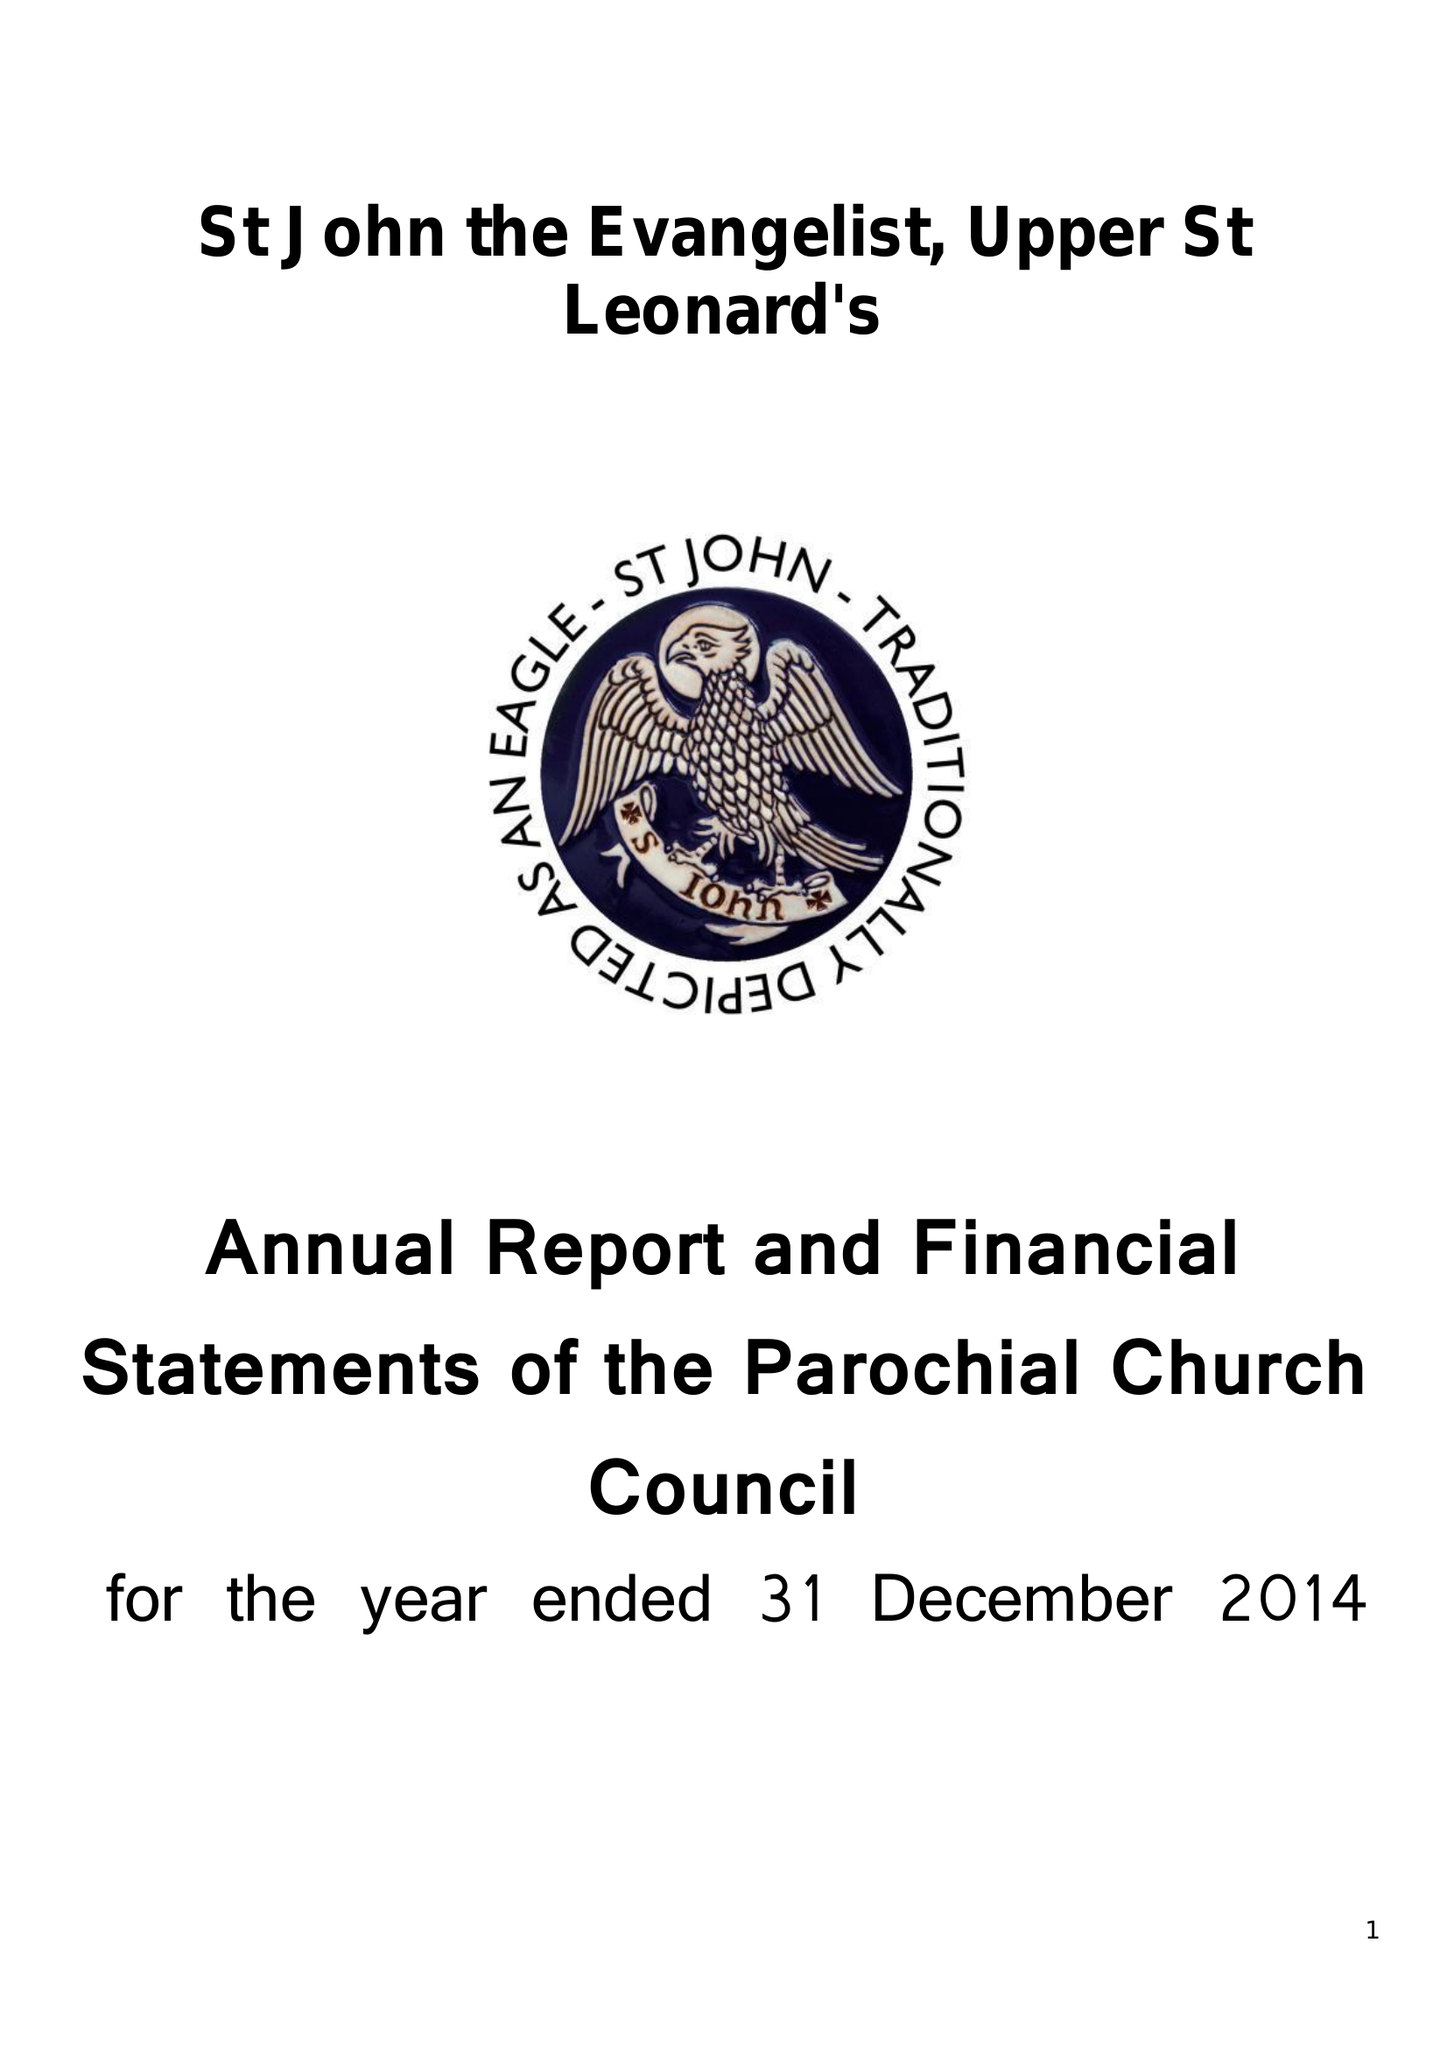What is the value for the spending_annually_in_british_pounds?
Answer the question using a single word or phrase. 181836.00 